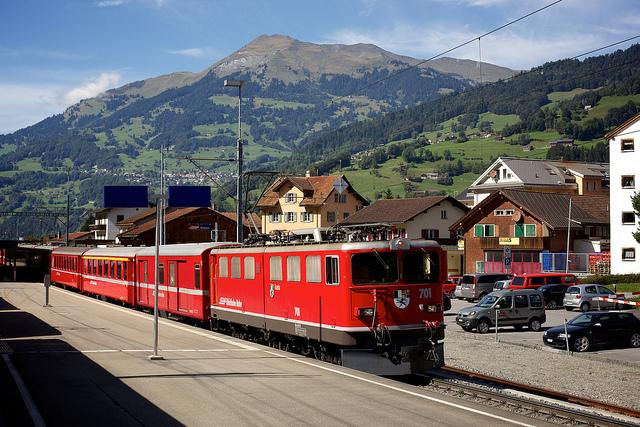Is this a passenger train?
Keep it brief. Yes. Is there snow on the hills?
Be succinct. No. How many cars are parked?
Answer briefly. 5. What color is the largest house?
Short answer required. White. Is there snow in the picture?
Write a very short answer. No. Is this a train station in a European town?
Short answer required. Yes. What color is the train?
Concise answer only. Red. 